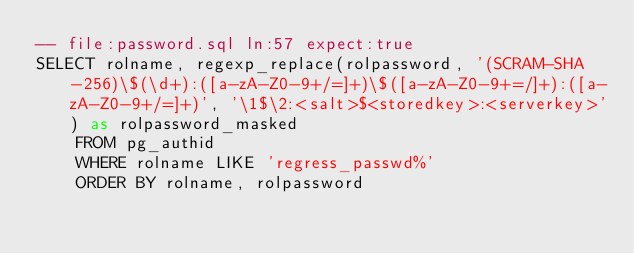Convert code to text. <code><loc_0><loc_0><loc_500><loc_500><_SQL_>-- file:password.sql ln:57 expect:true
SELECT rolname, regexp_replace(rolpassword, '(SCRAM-SHA-256)\$(\d+):([a-zA-Z0-9+/=]+)\$([a-zA-Z0-9+=/]+):([a-zA-Z0-9+/=]+)', '\1$\2:<salt>$<storedkey>:<serverkey>') as rolpassword_masked
    FROM pg_authid
    WHERE rolname LIKE 'regress_passwd%'
    ORDER BY rolname, rolpassword
</code> 